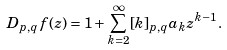<formula> <loc_0><loc_0><loc_500><loc_500>D _ { p , q } f ( z ) = 1 + \sum _ { k = 2 } ^ { \infty } [ k ] _ { p , q } a _ { k } z ^ { k - 1 } .</formula> 